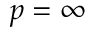Convert formula to latex. <formula><loc_0><loc_0><loc_500><loc_500>p = \infty</formula> 